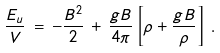<formula> <loc_0><loc_0><loc_500><loc_500>\frac { E _ { u } } { V } \, = \, - \frac { B ^ { 2 } } { 2 } \, + \, \frac { g B } { 4 \pi } \left [ \rho + \frac { g B } { \rho } \right ] \, .</formula> 